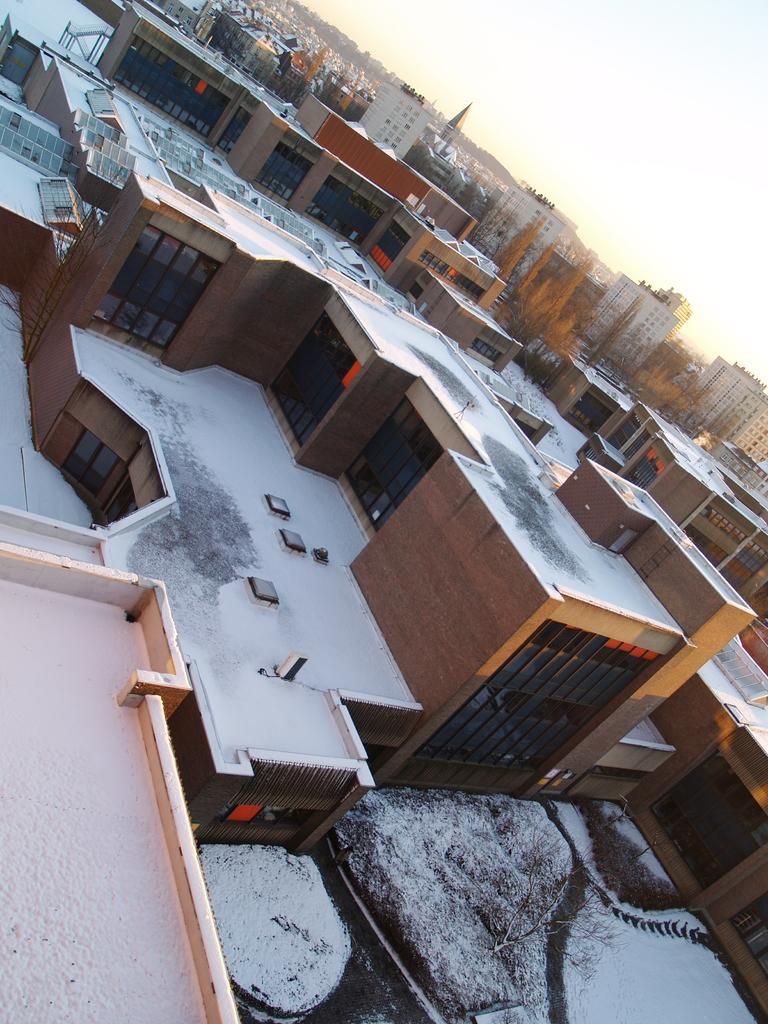How would you summarize this image in a sentence or two? This image is taken outdoors. At the top of the image there is a sky with clouds. In the middle of the image there are many buildings and houses with walls, windows, doors, roofs and balconies. At the bottom of the image there is a ground and it is covered with snow. 